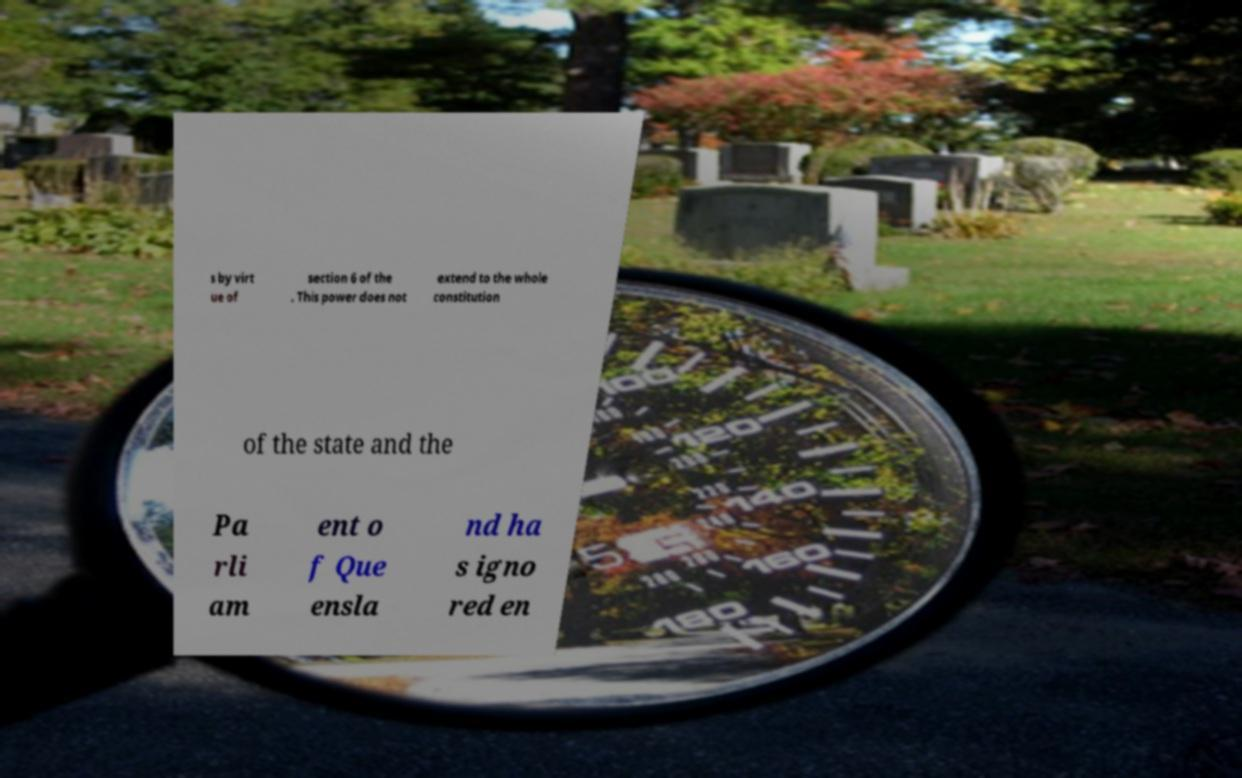Can you read and provide the text displayed in the image?This photo seems to have some interesting text. Can you extract and type it out for me? s by virt ue of section 6 of the . This power does not extend to the whole constitution of the state and the Pa rli am ent o f Que ensla nd ha s igno red en 